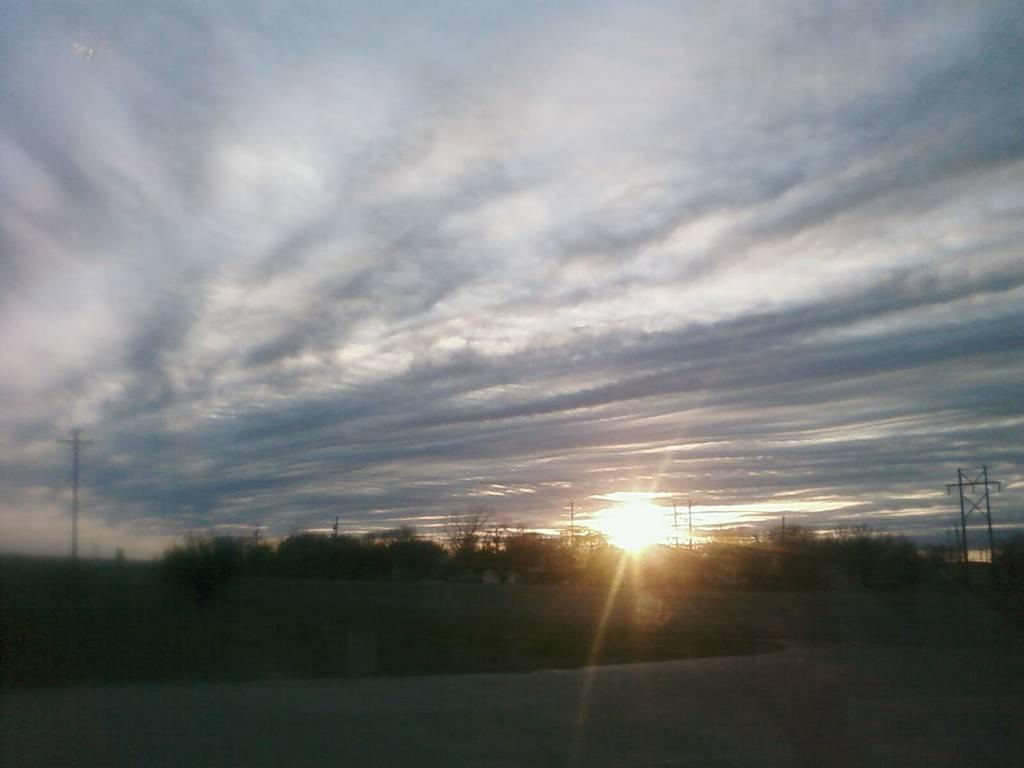What event is depicted in the image? The image depicts a sunrise. What is the primary source of light in the image? Bright sunshine is visible in the image. What type of natural vegetation is present in the image? There are trees in the image. Where is the sun located in relation to the trees? The sun is rising from behind the trees. What type of headwear is the spy wearing in the image? There is no spy present in the image, and therefore no headwear can be observed. Is there a light bulb visible in the image? There is no light bulb present in the image; the primary source of light is the sun. 